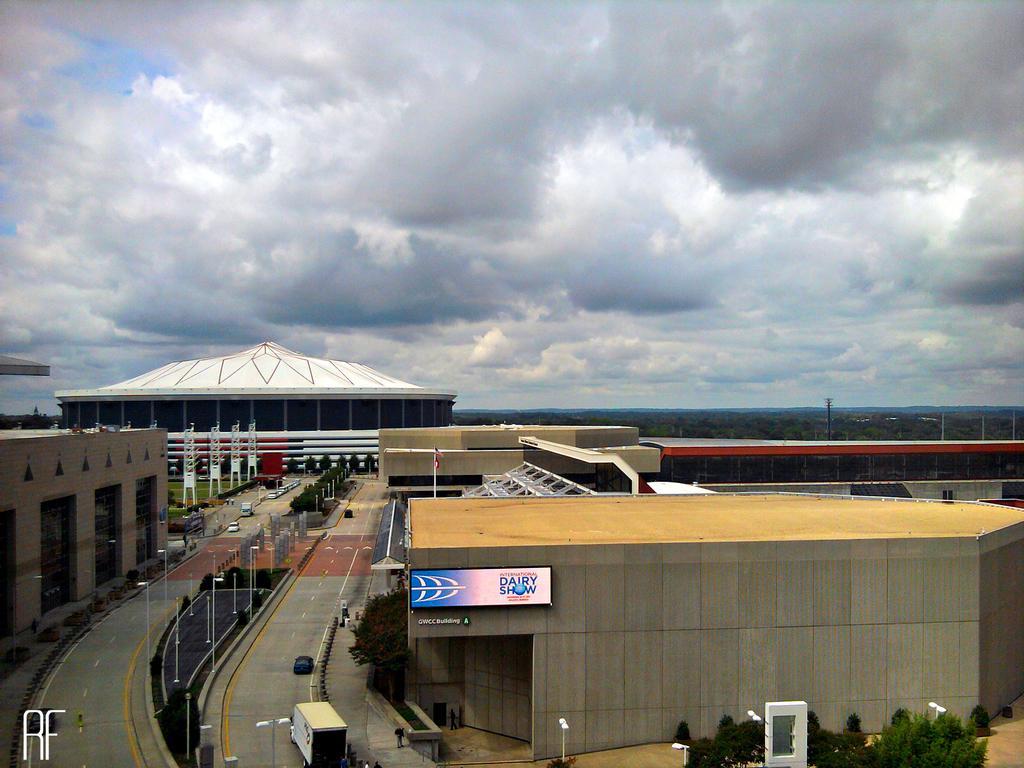Please provide a concise description of this image. In this image we can see sky with clouds, trees, towers, poles, buildings, iron grills, street lights, street poles, shrubs, bushes, motor vehicles and information boards. 